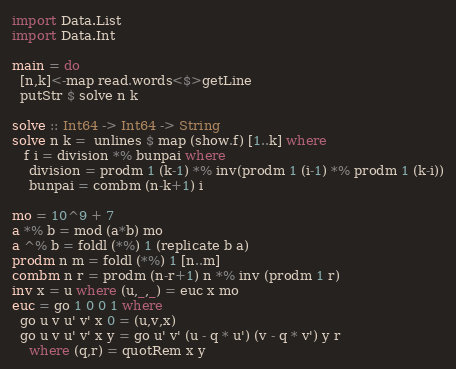<code> <loc_0><loc_0><loc_500><loc_500><_Haskell_>import Data.List
import Data.Int

main = do
  [n,k]<-map read.words<$>getLine
  putStr $ solve n k

solve :: Int64 -> Int64 -> String
solve n k =  unlines $ map (show.f) [1..k] where
   f i = division *% bunpai where
    division = prodm 1 (k-1) *% inv(prodm 1 (i-1) *% prodm 1 (k-i))
    bunpai = combm (n-k+1) i

mo = 10^9 + 7
a *% b = mod (a*b) mo
a ^% b = foldl (*%) 1 (replicate b a)
prodm n m = foldl (*%) 1 [n..m]
combm n r = prodm (n-r+1) n *% inv (prodm 1 r)
inv x = u where (u,_,_) = euc x mo
euc = go 1 0 0 1 where
  go u v u' v' x 0 = (u,v,x)
  go u v u' v' x y = go u' v' (u - q * u') (v - q * v') y r
    where (q,r) = quotRem x y</code> 